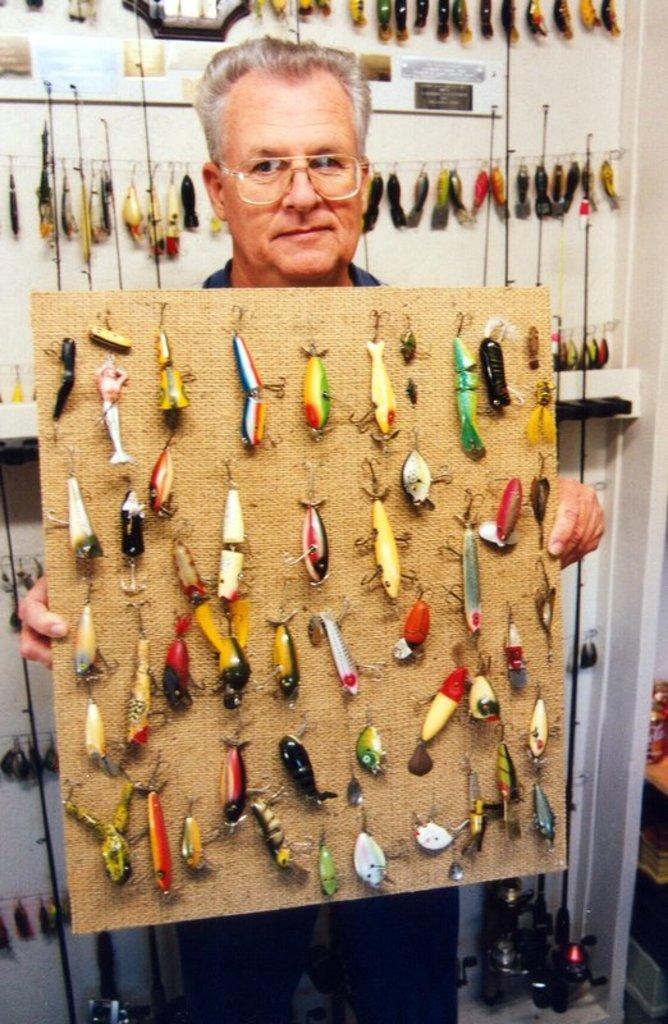How would you summarize this image in a sentence or two? In this image I can see a person holding a board. I can see some objects on the board. In the background, I can see some objects hanging on the wire near the wall. 